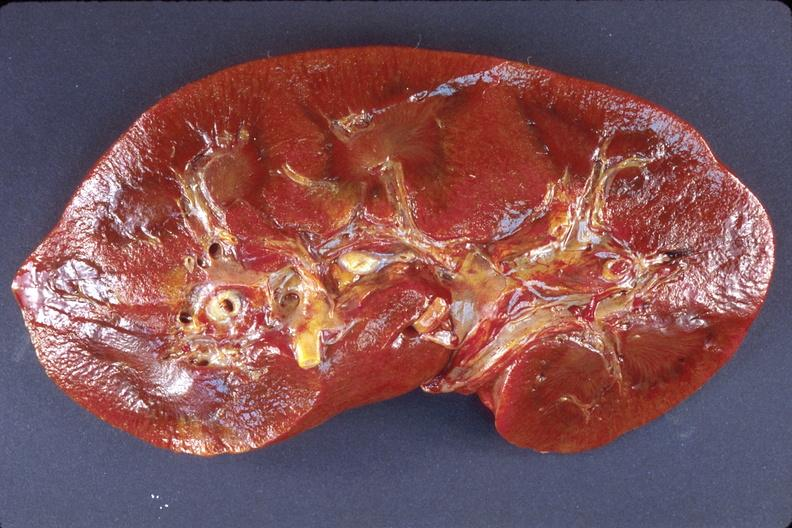does this image show kidney, amyloidosis?
Answer the question using a single word or phrase. Yes 